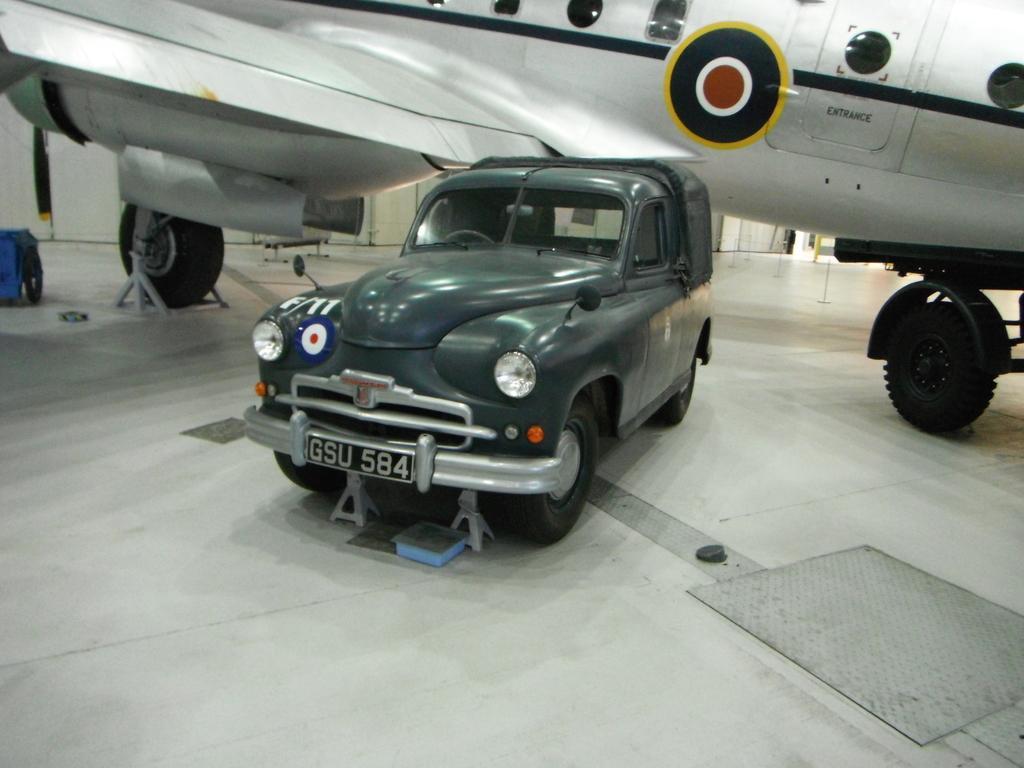How would you summarize this image in a sentence or two? Here we can plane and car. To this car there is a number plate and headlight. To this plane there are windows, wheels and door. This is white surface. 